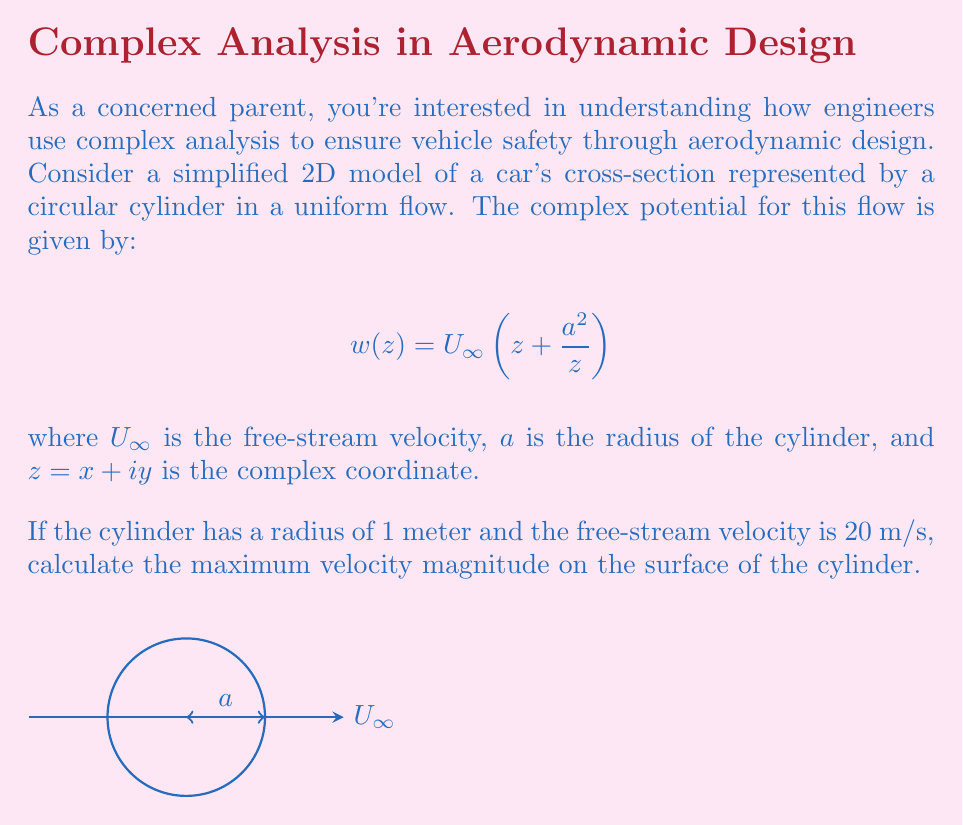Help me with this question. Let's approach this step-by-step:

1) The complex velocity potential $w(z)$ is given. To find the velocity, we need to differentiate this with respect to $z$:

   $$\frac{dw}{dz} = U_\infty(1 - \frac{a^2}{z^2})$$

2) This complex velocity can be written as $u - iv$, where $u$ and $v$ are the x and y components of velocity respectively.

3) On the surface of the cylinder, $z = ae^{i\theta}$, where $\theta$ is the angle from the x-axis. Substituting this:

   $$\frac{dw}{dz} = U_\infty(1 - e^{-2i\theta})$$

4) The velocity magnitude is given by the absolute value of this complex velocity:

   $$|\frac{dw}{dz}| = U_\infty|1 - e^{-2i\theta}| = U_\infty\sqrt{(1-\cos 2\theta)^2 + \sin^2 2\theta}$$

5) Simplifying:

   $$|\frac{dw}{dz}| = U_\infty\sqrt{1 - 2\cos 2\theta + \cos^2 2\theta + \sin^2 2\theta} = U_\infty\sqrt{2 - 2\cos 2\theta}$$

6) The maximum velocity occurs when $\cos 2\theta = -1$, or when $\theta = \frac{\pi}{2}$ or $\frac{3\pi}{2}$. At these points:

   $$|\frac{dw}{dz}|_{max} = U_\infty\sqrt{2 - 2(-1)} = U_\infty\sqrt{4} = 2U_\infty$$

7) Given $U_\infty = 20$ m/s, the maximum velocity magnitude is:

   $$|\frac{dw}{dz}|_{max} = 2 * 20 = 40 \text{ m/s}$$
Answer: 40 m/s 